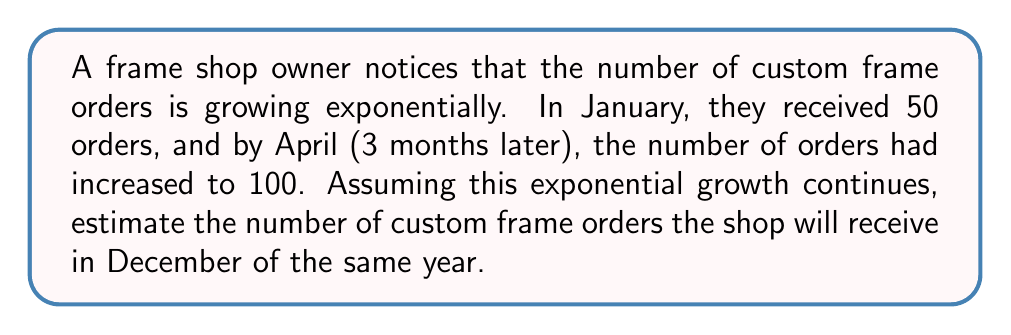Solve this math problem. To solve this problem, we'll use the exponential growth model:

$$A = P(1 + r)^t$$

Where:
$A$ = Final amount
$P$ = Initial amount
$r$ = Growth rate (per month)
$t$ = Time (in months)

Step 1: Determine the growth rate
We know that:
$P = 50$ (January orders)
$A = 100$ (April orders)
$t = 3$ (3 months between January and April)

Substitute these values into the equation:
$$100 = 50(1 + r)^3$$

Step 2: Solve for r
$$2 = (1 + r)^3$$
$$\sqrt[3]{2} = 1 + r$$
$$r = \sqrt[3]{2} - 1 \approx 0.2599$$ or about 26% per month

Step 3: Calculate the number of orders in December
From January to December is 11 months, so $t = 11$

Use the exponential growth formula again:
$$A = 50(1 + 0.2599)^{11}$$

Step 4: Evaluate the expression
$$A = 50(1.2599)^{11} \approx 825.76$$

Step 5: Round to the nearest whole number
Since we can't have a fractional order, we round to 826.
Answer: 826 orders 